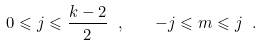Convert formula to latex. <formula><loc_0><loc_0><loc_500><loc_500>0 \leqslant j \leqslant \frac { k - 2 } { 2 } \ , \quad - j \leqslant m \leqslant j \ .</formula> 